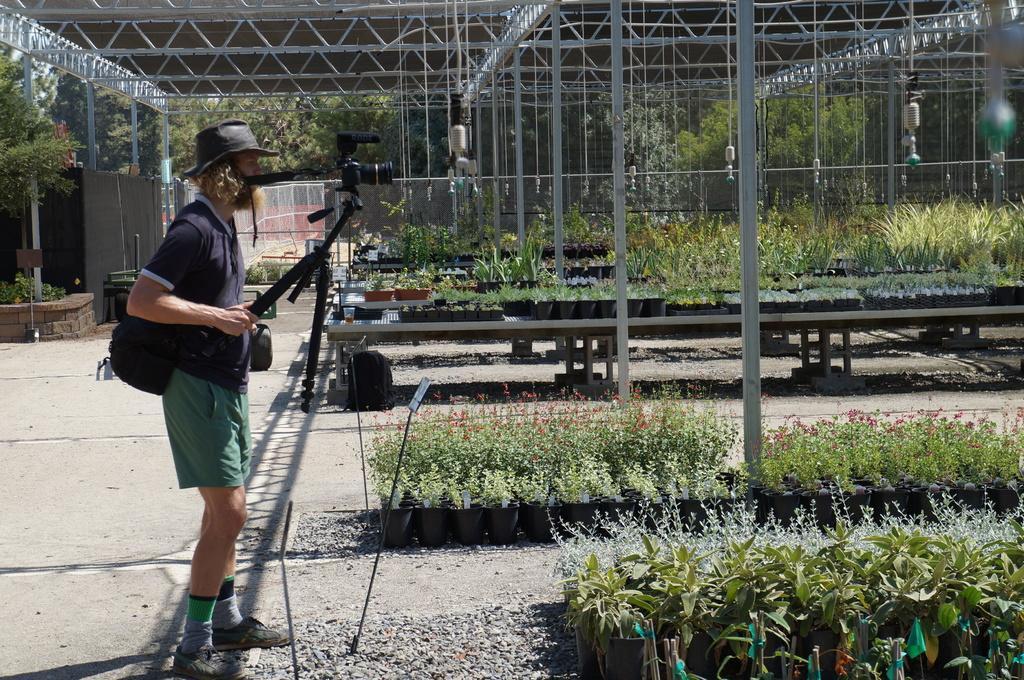What is the main subject of the image? The main subject of the image is a man. What is the man wearing on his head? The man is wearing a cap. What is the man holding in the image? The man is holding a stand with his hand. Where is the man standing in the image? The man is standing on the ground. What else can be seen in the image besides the man? There is a bag, poles, plants, and trees in the background of the image. How many rings can be seen on the man's fingers in the image? There are no rings visible on the man's fingers in the image. 